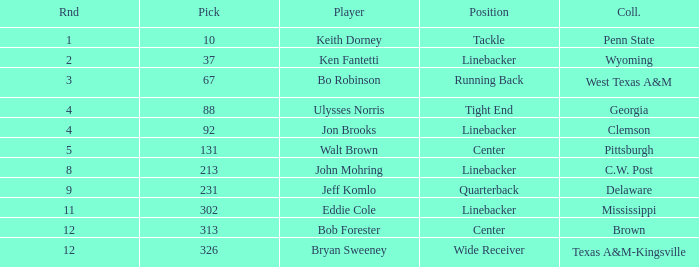What is the college pick for 213? C.W. Post. 